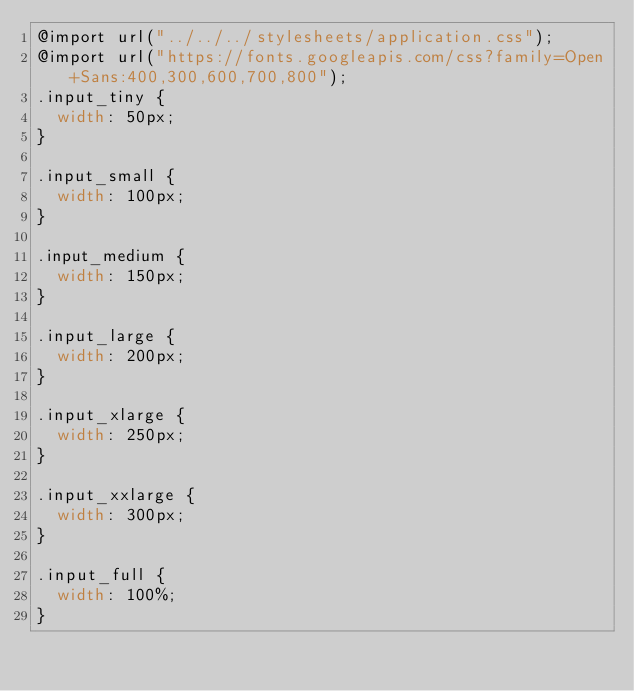Convert code to text. <code><loc_0><loc_0><loc_500><loc_500><_CSS_>@import url("../../../stylesheets/application.css");
@import url("https://fonts.googleapis.com/css?family=Open+Sans:400,300,600,700,800");
.input_tiny {
  width: 50px;
}

.input_small {
  width: 100px;
}

.input_medium {
  width: 150px;
}

.input_large {
  width: 200px;
}

.input_xlarge {
  width: 250px;
}

.input_xxlarge {
  width: 300px;
}

.input_full {
  width: 100%;
}
</code> 